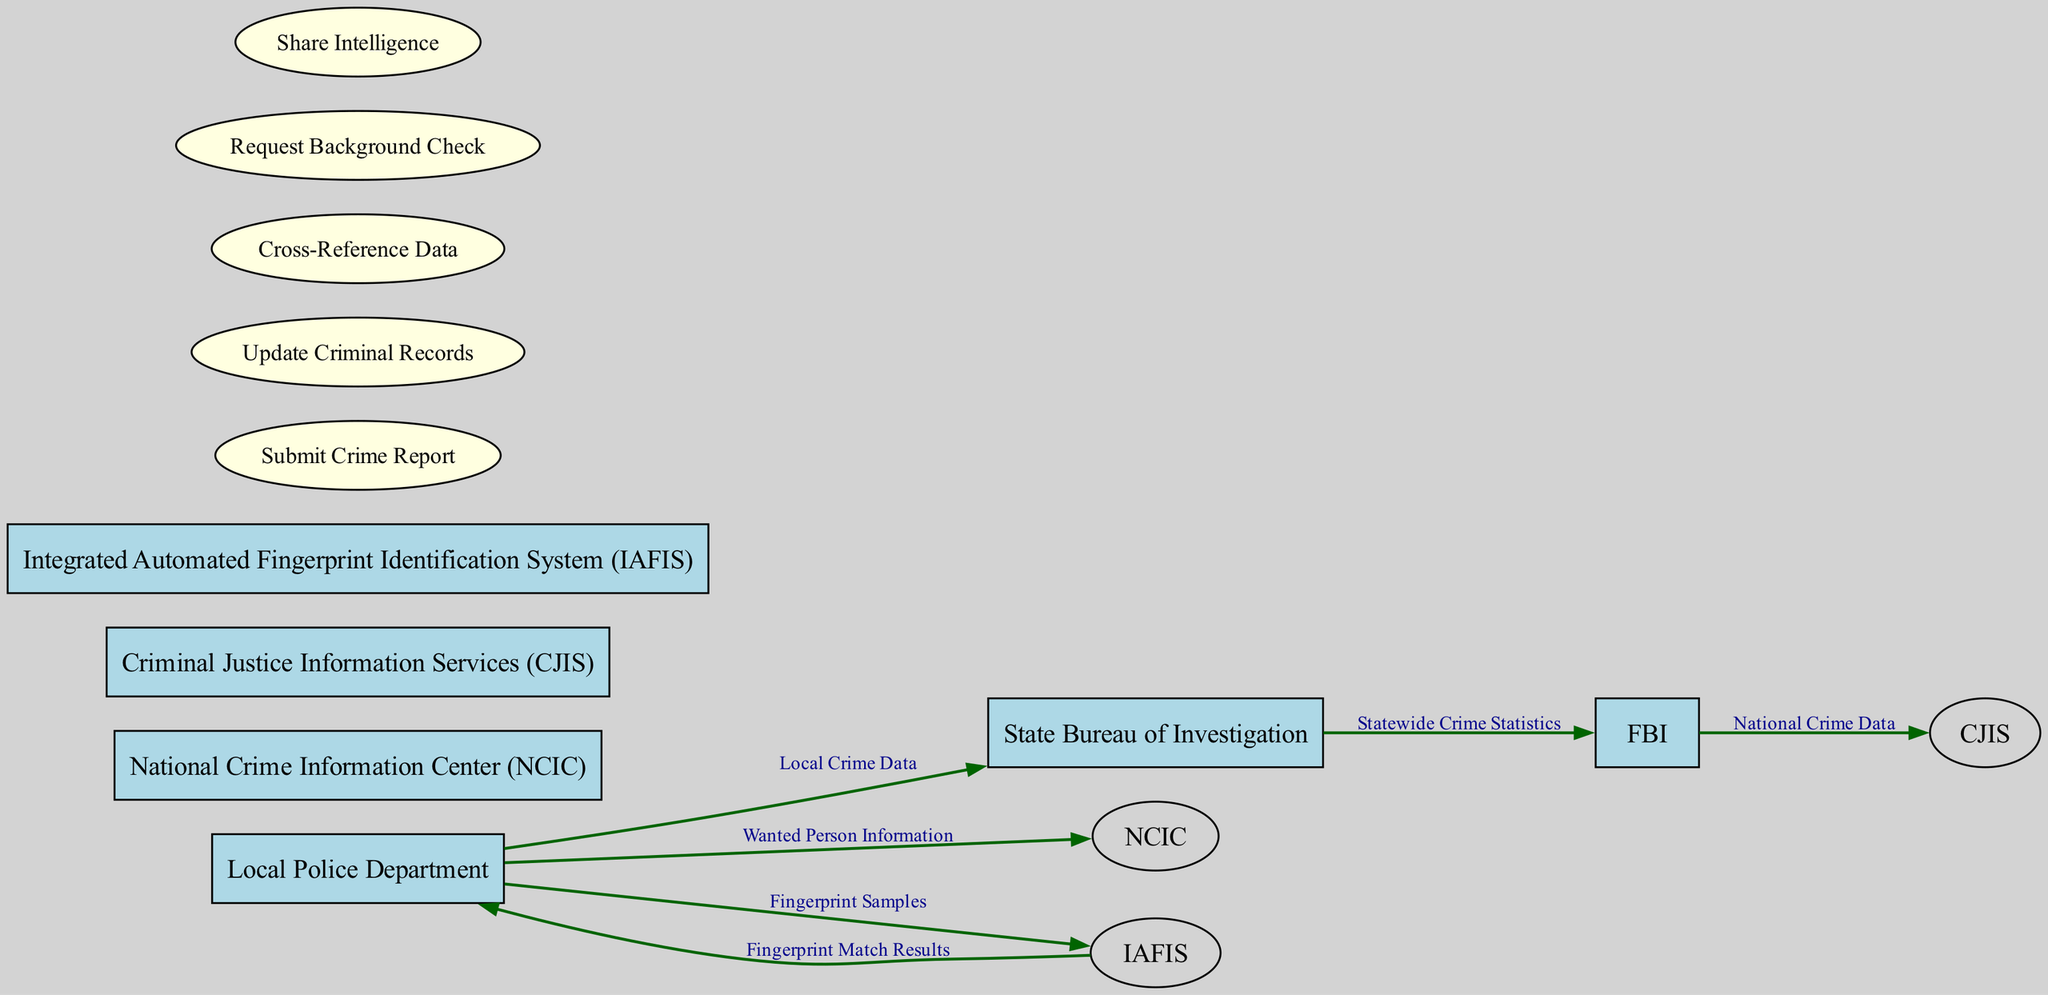What are the entities represented in the diagram? The entities represented in the diagram are listed individually. By examining the node boxes in the diagram, you can identify the six entities: Local Police Department, State Bureau of Investigation, FBI, National Crime Information Center, Criminal Justice Information Services, and Integrated Automated Fingerprint Identification System.
Answer: Local Police Department, State Bureau of Investigation, FBI, National Crime Information Center, Criminal Justice Information Services, Integrated Automated Fingerprint Identification System How many data flows are illustrated in the diagram? To find the number of data flows, you can count the directed edges connecting the entities and the processes in the diagram. There are a total of six data flows shown connecting various entities.
Answer: 6 What type of data is shared between the Local Police Department and State Bureau of Investigation? By examining the data flows, you can see the label on the edge connecting the Local Police Department and the State Bureau of Investigation, which indicates that the data exchanged is "Local Crime Data."
Answer: Local Crime Data Which entity receives the Fingerprint Match Results? The diagram shows an edge flowing from the Integrated Automated Fingerprint Identification System to the Local Police Department, indicating that this entity receives the Fingerprint Match Results.
Answer: Local Police Department Which process does the Local Police Department initiate regarding Wanted Person Information? The diagram indicates that the Local Police Department has a data flow directed to the National Crime Information Center with the data labeled as "Wanted Person Information." This flow corresponds to the process of submitting crime reports.
Answer: Submit Crime Report What is the last entity to receive National Crime Data? Following the flows in the diagram, you can trace the path of "National Crime Data" that starts from the FBI. The last entity to receive this data, as indicated in the data flow, is the Criminal Justice Information Services.
Answer: Criminal Justice Information Services How many processes are depicted in the diagram? By counting the ellipses (process nodes) in the diagram that represent processes, you can determine their total number. There are five processes illustrated in the diagram.
Answer: 5 What relationship exists between IAFIS and Local Police Department? Observing the edges in the diagram, there is a directed flow from the Integrated Automated Fingerprint Identification System to the Local Police Department indicating that the Local Police Department receives data from IAFIS. This flow represents the output of fingerprint match results.
Answer: Local Police Department receives Fingerprint Match Results What is exchanged between the State Bureau of Investigation and the FBI? The directed edge that connects the State Bureau of Investigation to the FBI shows that they exchange "Statewide Crime Statistics" data. This provides insight into the nature of the data shared between these entities.
Answer: Statewide Crime Statistics 